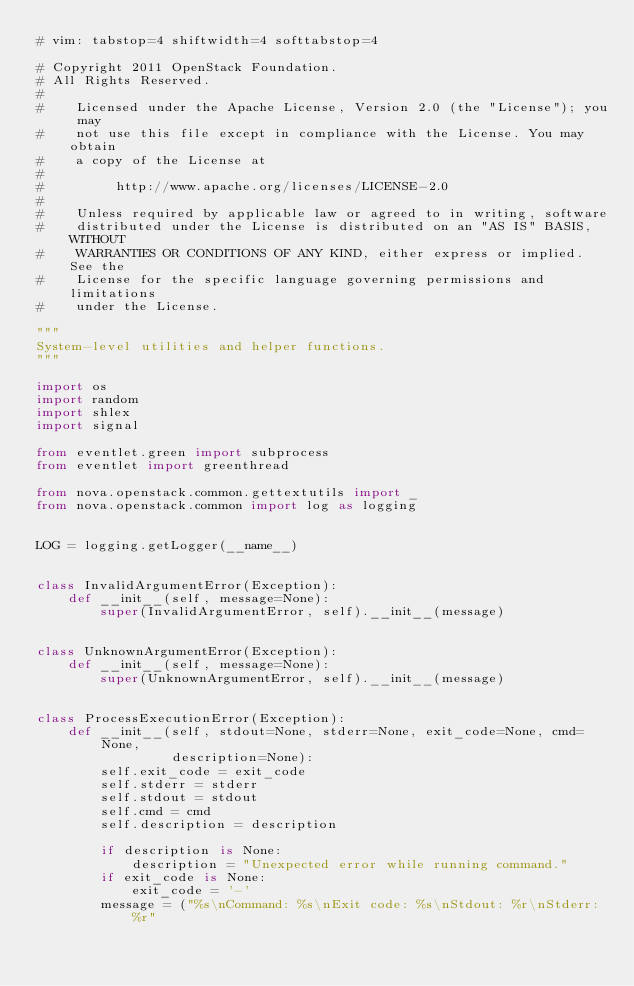Convert code to text. <code><loc_0><loc_0><loc_500><loc_500><_Python_># vim: tabstop=4 shiftwidth=4 softtabstop=4

# Copyright 2011 OpenStack Foundation.
# All Rights Reserved.
#
#    Licensed under the Apache License, Version 2.0 (the "License"); you may
#    not use this file except in compliance with the License. You may obtain
#    a copy of the License at
#
#         http://www.apache.org/licenses/LICENSE-2.0
#
#    Unless required by applicable law or agreed to in writing, software
#    distributed under the License is distributed on an "AS IS" BASIS, WITHOUT
#    WARRANTIES OR CONDITIONS OF ANY KIND, either express or implied. See the
#    License for the specific language governing permissions and limitations
#    under the License.

"""
System-level utilities and helper functions.
"""

import os
import random
import shlex
import signal

from eventlet.green import subprocess
from eventlet import greenthread

from nova.openstack.common.gettextutils import _
from nova.openstack.common import log as logging


LOG = logging.getLogger(__name__)


class InvalidArgumentError(Exception):
    def __init__(self, message=None):
        super(InvalidArgumentError, self).__init__(message)


class UnknownArgumentError(Exception):
    def __init__(self, message=None):
        super(UnknownArgumentError, self).__init__(message)


class ProcessExecutionError(Exception):
    def __init__(self, stdout=None, stderr=None, exit_code=None, cmd=None,
                 description=None):
        self.exit_code = exit_code
        self.stderr = stderr
        self.stdout = stdout
        self.cmd = cmd
        self.description = description

        if description is None:
            description = "Unexpected error while running command."
        if exit_code is None:
            exit_code = '-'
        message = ("%s\nCommand: %s\nExit code: %s\nStdout: %r\nStderr: %r"</code> 